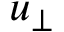<formula> <loc_0><loc_0><loc_500><loc_500>u _ { \perp }</formula> 